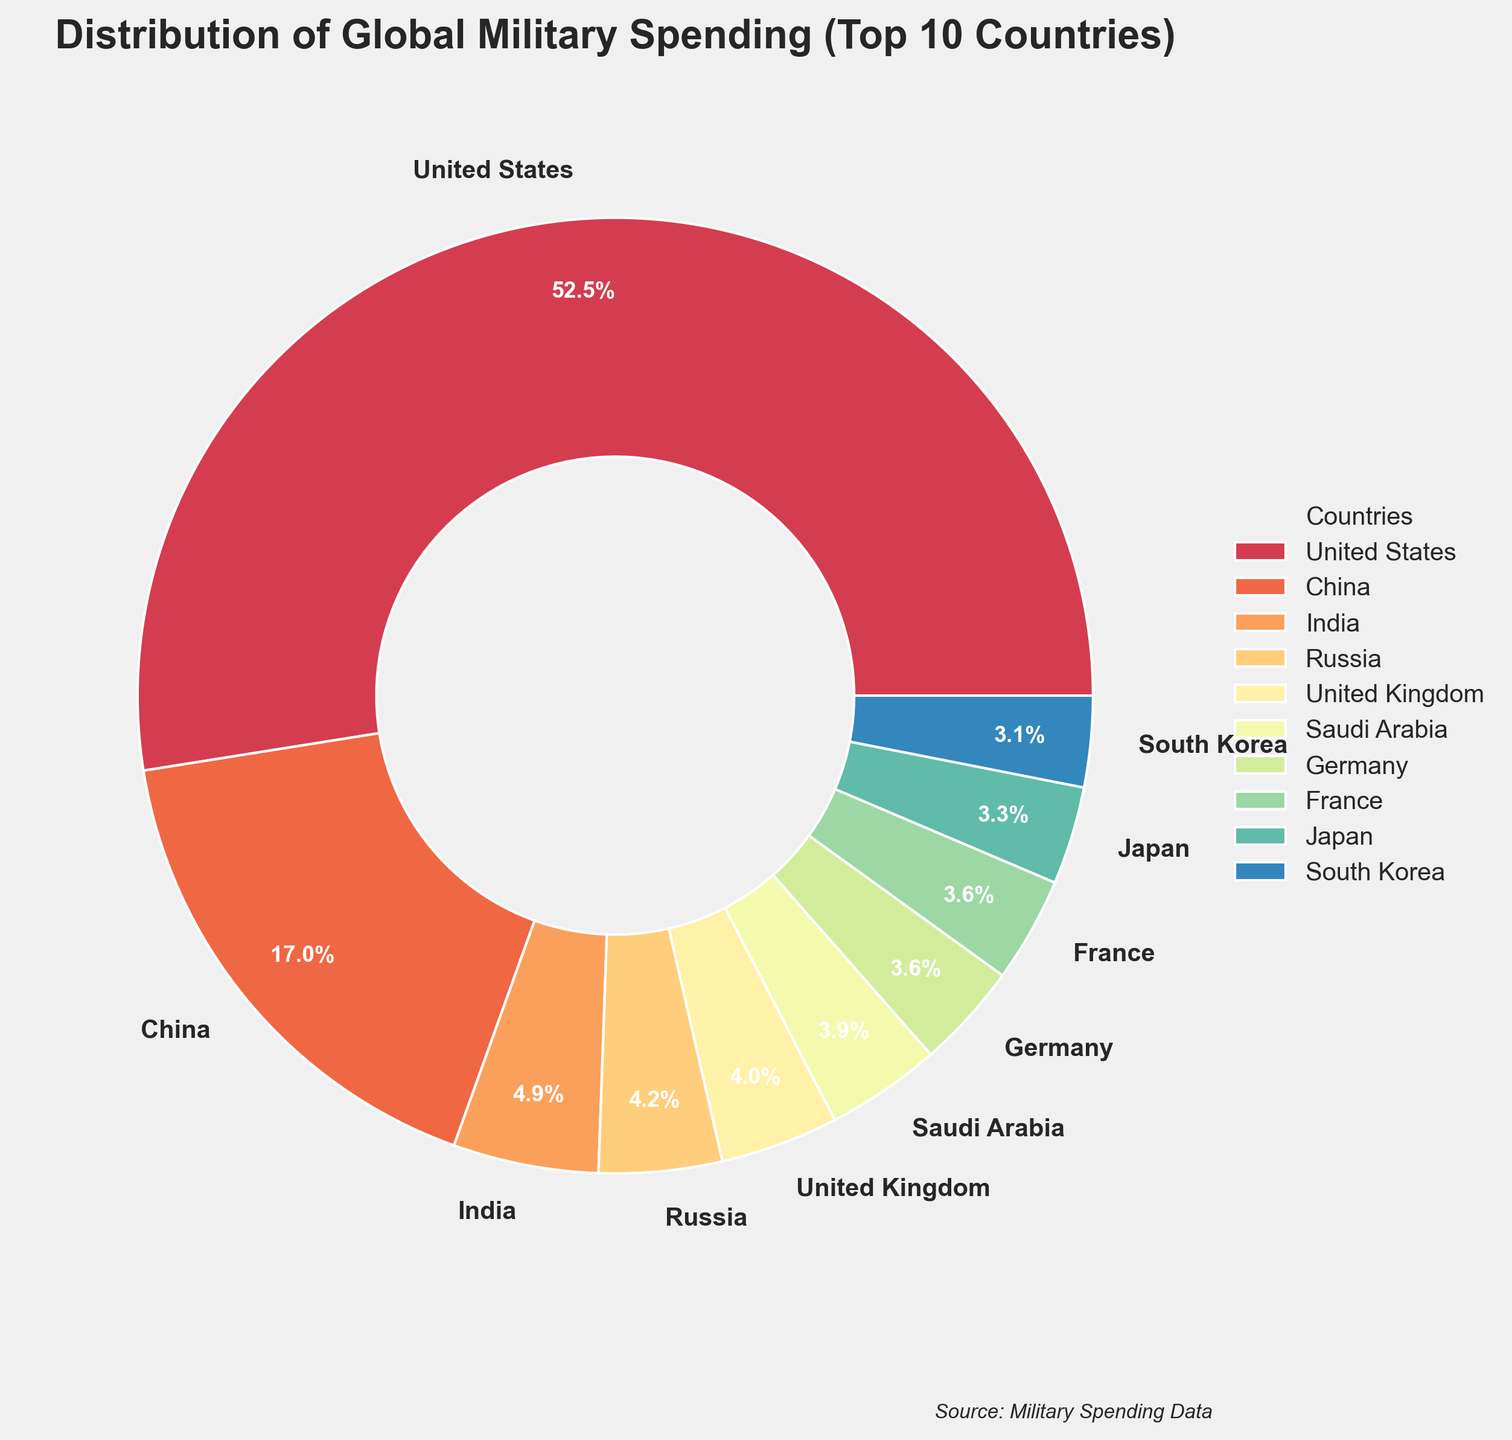Which country has the highest military spending? To find the country with the highest military spending in the pie chart, look for the largest slice. The largest slice is labeled "United States" with military spending of 778 billion USD.
Answer: United States Which two countries together contribute more than 50% of the total spending? To determine which two countries together contribute more than 50%, identify the largest slices and sum their percentages. The United States and China, with 39.6% and 12.8% respectively, together contribute 52.4% of total spending.
Answer: United States and China How much more does the United States spend compared to China? Note the spending values for both countries from their respective slices. The United States spends 778 billion USD, and China spends 252 billion USD. Subtract China's spending from the United States' spending: 778 - 252 = 526 billion USD.
Answer: 526 billion USD Which country has the smallest share of military spending among the top 10? Identify the smallest slice in the pie chart. The slice with the label "South Korea" is the smallest, with spending of 45.7 billion USD.
Answer: South Korea How does the military spending of India compare to that of Russia? Compare the sizes of the slices for India and Russia. India's spending is 72.9 billion USD, while Russia's spending is 61.7 billion USD. Since 72.9 is greater than 61.7, India spends more than Russia.
Answer: India spends more What is the total military spending of Germany and France combined? To find the combined spending of Germany and France, add their individual spending values. Germany's spending is 52.8 billion USD, and France's is 52.7 billion USD. Their combined spending is 52.8 + 52.7 = 105.5 billion USD.
Answer: 105.5 billion USD Which of the top 10 countries in military spending have spending amounts closest to each other? By visually comparing the sizes of the slices, you can see that Germany and France have nearly equal sizes. Their spending amounts are very close: 52.8 billion USD for Germany and 52.7 billion USD for France.
Answer: Germany and France What percentage of the total does Japan represent in military spending? Look at Japan’s slice and its percentage label. Japan’s military spending percentage of the total is marked as 6.3%.
Answer: 6.3% Rank the top 3 countries in terms of military spending from highest to lowest. Identify the three largest slices in the pie chart and their labels. The top 3 countries are: 1) United States, 2) China, 3) India.
Answer: 1) United States, 2) China, 3) India 